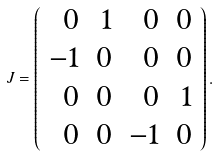Convert formula to latex. <formula><loc_0><loc_0><loc_500><loc_500>J = \left ( \begin{array} { r r r r } 0 & 1 & 0 & 0 \\ - 1 & 0 & 0 & 0 \\ 0 & 0 & 0 & 1 \\ 0 & 0 & - 1 & 0 \end{array} \right ) .</formula> 